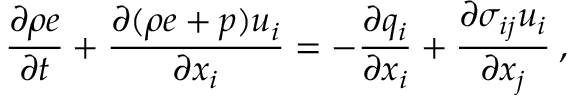<formula> <loc_0><loc_0><loc_500><loc_500>\frac { \partial \rho e } { \partial t } + \frac { \partial ( \rho e + p ) u _ { i } } { \partial x _ { i } } = - \frac { \partial q _ { i } } { \partial x _ { i } } + \frac { \partial \sigma _ { i j } u _ { i } } { \partial x _ { j } } \, ,</formula> 